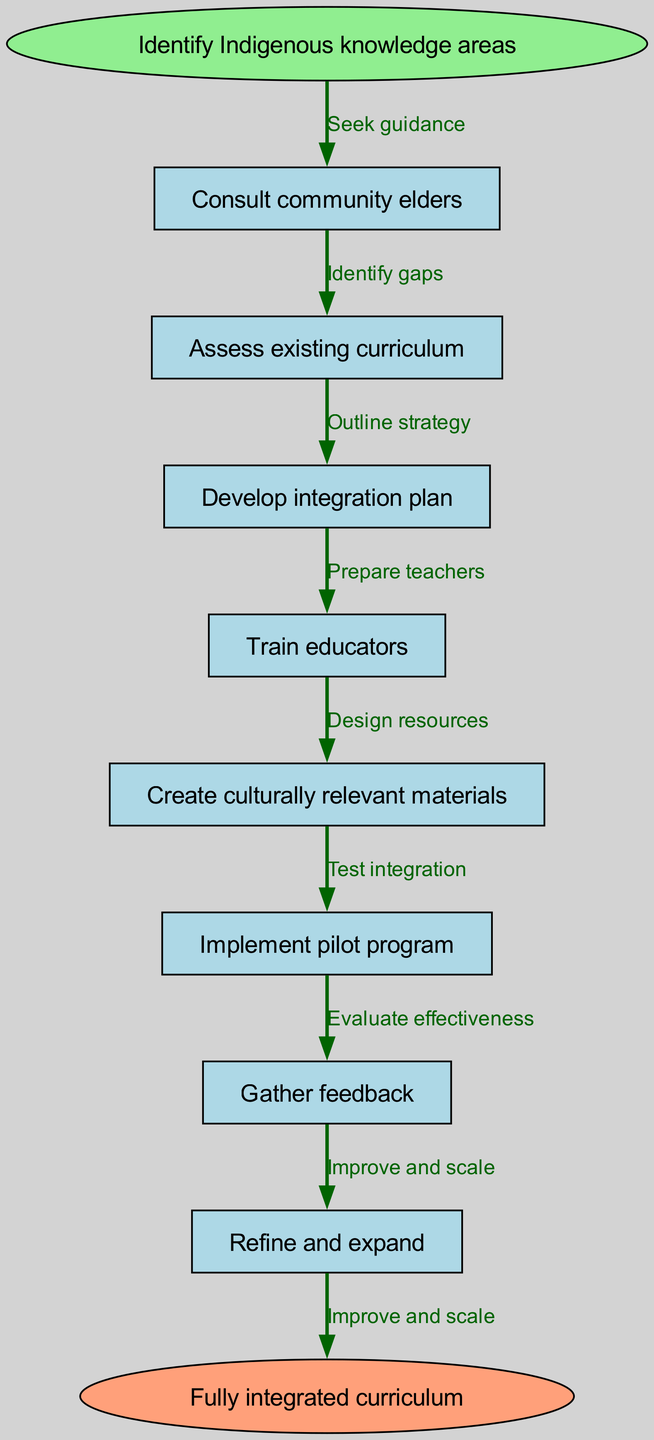What is the first step in the process? The first step is represented by the 'start' node which is "Identify Indigenous knowledge areas."
Answer: Identify Indigenous knowledge areas How many nodes are in this diagram? The diagram contains a total of 8 nodes: 1 start, 6 process steps, and 1 end node.
Answer: 8 What relationship connects "Assess existing curriculum" to "Develop integration plan"? The edge connecting these two nodes is labeled "Identify gaps," indicating the relationship of finding deficiencies in the current curriculum before moving to the next phase of integration planning.
Answer: Identify gaps Which node follows "Gather feedback"? The node that follows "Gather feedback" is "Refine and expand," illustrating that after collecting feedback, the next step is to refine the methods used and expand upon the initial efforts.
Answer: Refine and expand What is the last node in the process? The last node is the 'end' node labeled "Fully integrated curriculum," which signifies the ultimate goal of the integration process.
Answer: Fully integrated curriculum How is "Train educators" connected in the process? "Train educators" is connected to "Develop integration plan" through the edge labeled "Prepare teachers," indicating that training is part of executing the integration plan.
Answer: Prepare teachers What step comes before "Create culturally relevant materials"? The step that comes before "Create culturally relevant materials" is "Train educators," showcasing the necessity of educator training before developing the appropriate material.
Answer: Train educators What action is taken after "Implement pilot program"? The action taken after "Implement pilot program" is "Gather feedback," meaning that the effects of the pilot program are assessed subsequently.
Answer: Gather feedback 